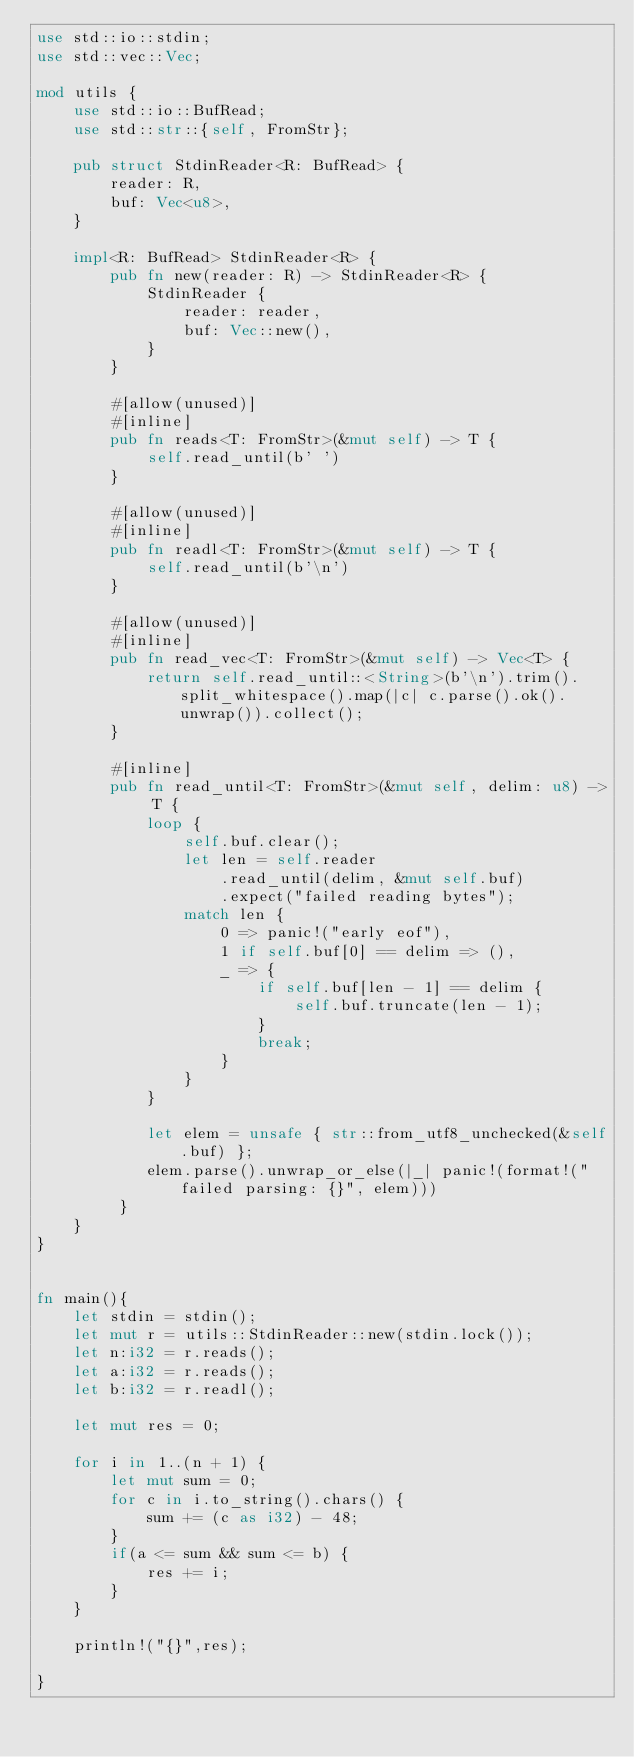Convert code to text. <code><loc_0><loc_0><loc_500><loc_500><_Rust_>use std::io::stdin;
use std::vec::Vec;

mod utils {
    use std::io::BufRead;
    use std::str::{self, FromStr};

    pub struct StdinReader<R: BufRead> {
        reader: R,
        buf: Vec<u8>,
    }

    impl<R: BufRead> StdinReader<R> {
        pub fn new(reader: R) -> StdinReader<R> {
            StdinReader {
                reader: reader,
                buf: Vec::new(),
            }
        }

        #[allow(unused)]
        #[inline]
        pub fn reads<T: FromStr>(&mut self) -> T {
            self.read_until(b' ')
        }

        #[allow(unused)]
        #[inline]
        pub fn readl<T: FromStr>(&mut self) -> T {
            self.read_until(b'\n')
        }

        #[allow(unused)]
        #[inline]
        pub fn read_vec<T: FromStr>(&mut self) -> Vec<T> {
            return self.read_until::<String>(b'\n').trim().split_whitespace().map(|c| c.parse().ok().unwrap()).collect();
        }

        #[inline]
        pub fn read_until<T: FromStr>(&mut self, delim: u8) -> T {
            loop {
                self.buf.clear();
                let len = self.reader
                    .read_until(delim, &mut self.buf)
                    .expect("failed reading bytes");
                match len {
                    0 => panic!("early eof"),
                    1 if self.buf[0] == delim => (),
                    _ => {
                        if self.buf[len - 1] == delim {
                            self.buf.truncate(len - 1);
                        }
                        break;
                    }
                }
            }

            let elem = unsafe { str::from_utf8_unchecked(&self.buf) };
            elem.parse().unwrap_or_else(|_| panic!(format!("failed parsing: {}", elem)))
         }
    }
}


fn main(){
    let stdin = stdin();
    let mut r = utils::StdinReader::new(stdin.lock());
    let n:i32 = r.reads();
    let a:i32 = r.reads();
    let b:i32 = r.readl();

    let mut res = 0;
    
    for i in 1..(n + 1) {
        let mut sum = 0;
        for c in i.to_string().chars() {
            sum += (c as i32) - 48;
        }
        if(a <= sum && sum <= b) {
            res += i;
        }
    }

    println!("{}",res);

}
</code> 